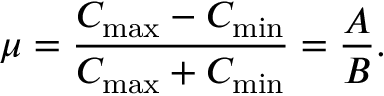<formula> <loc_0><loc_0><loc_500><loc_500>\mu = \frac { C _ { \max } - C _ { \min } } { C _ { \max } + C _ { \min } } = \frac { A } { B } .</formula> 